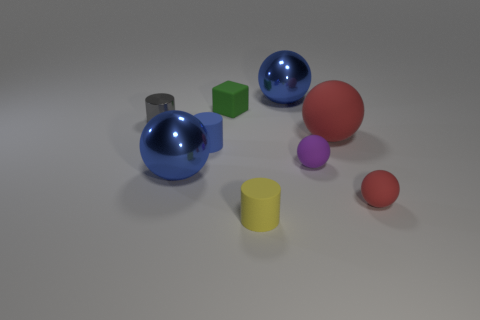What number of objects are red rubber spheres that are behind the small red matte ball or green matte cubes that are behind the tiny yellow thing? Upon examining the image, I can determine that there is one red rubber sphere located behind the small red matte ball. As for green matte cubes behind the tiny yellow object, there is one such cube. Therefore, the total count of relevant objects described in the question is two. 